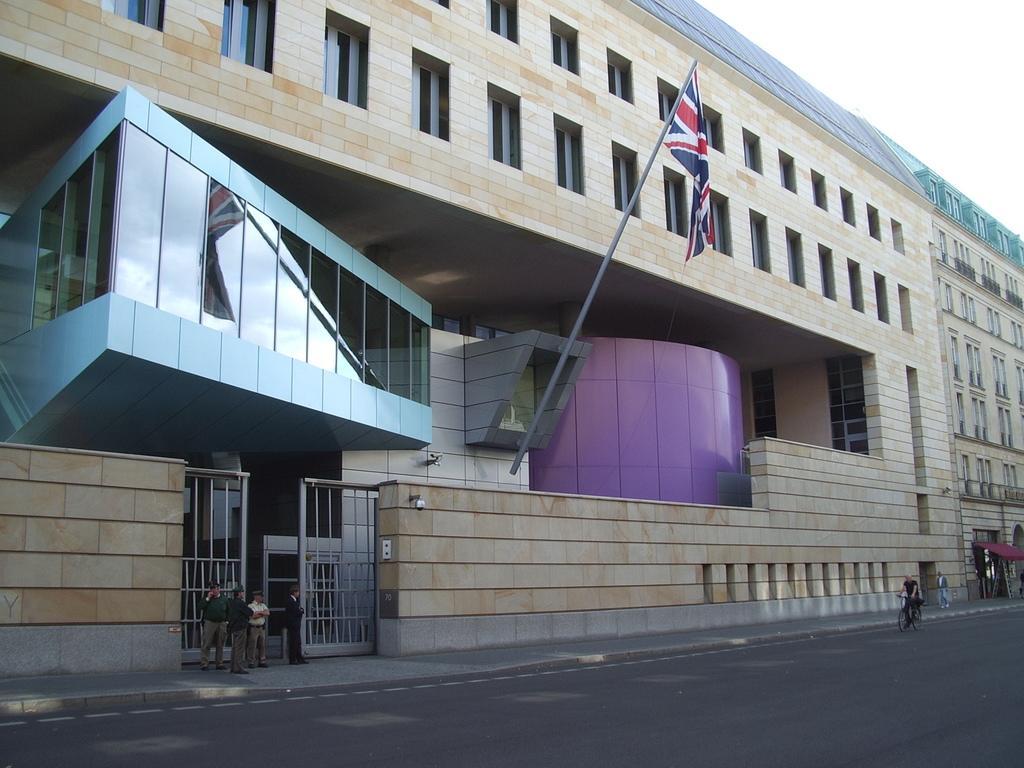Please provide a concise description of this image. This is the front view of a building, there is a flag to a pole on the building, in front of the building there are a few people standing in front of the gate, in front of the building there is a person riding a bicycle on the road. 